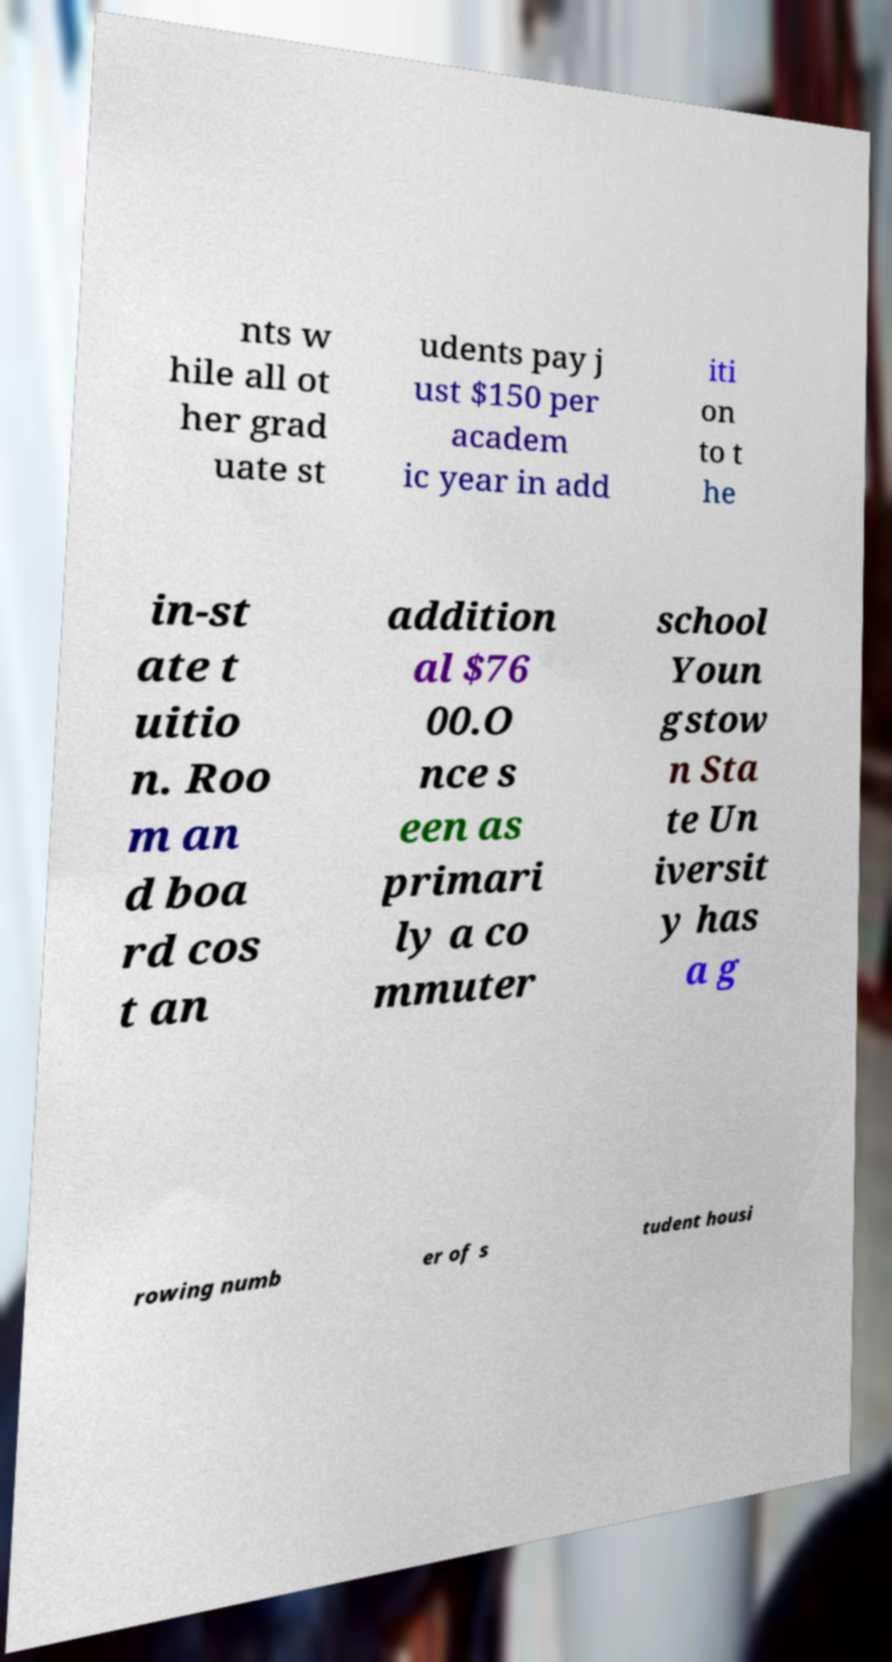Can you accurately transcribe the text from the provided image for me? nts w hile all ot her grad uate st udents pay j ust $150 per academ ic year in add iti on to t he in-st ate t uitio n. Roo m an d boa rd cos t an addition al $76 00.O nce s een as primari ly a co mmuter school Youn gstow n Sta te Un iversit y has a g rowing numb er of s tudent housi 